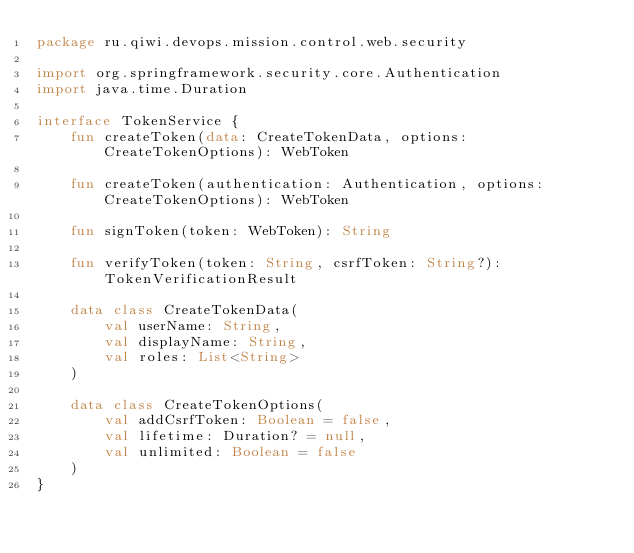Convert code to text. <code><loc_0><loc_0><loc_500><loc_500><_Kotlin_>package ru.qiwi.devops.mission.control.web.security

import org.springframework.security.core.Authentication
import java.time.Duration

interface TokenService {
    fun createToken(data: CreateTokenData, options: CreateTokenOptions): WebToken

    fun createToken(authentication: Authentication, options: CreateTokenOptions): WebToken

    fun signToken(token: WebToken): String

    fun verifyToken(token: String, csrfToken: String?): TokenVerificationResult

    data class CreateTokenData(
        val userName: String,
        val displayName: String,
        val roles: List<String>
    )

    data class CreateTokenOptions(
        val addCsrfToken: Boolean = false,
        val lifetime: Duration? = null,
        val unlimited: Boolean = false
    )
}</code> 